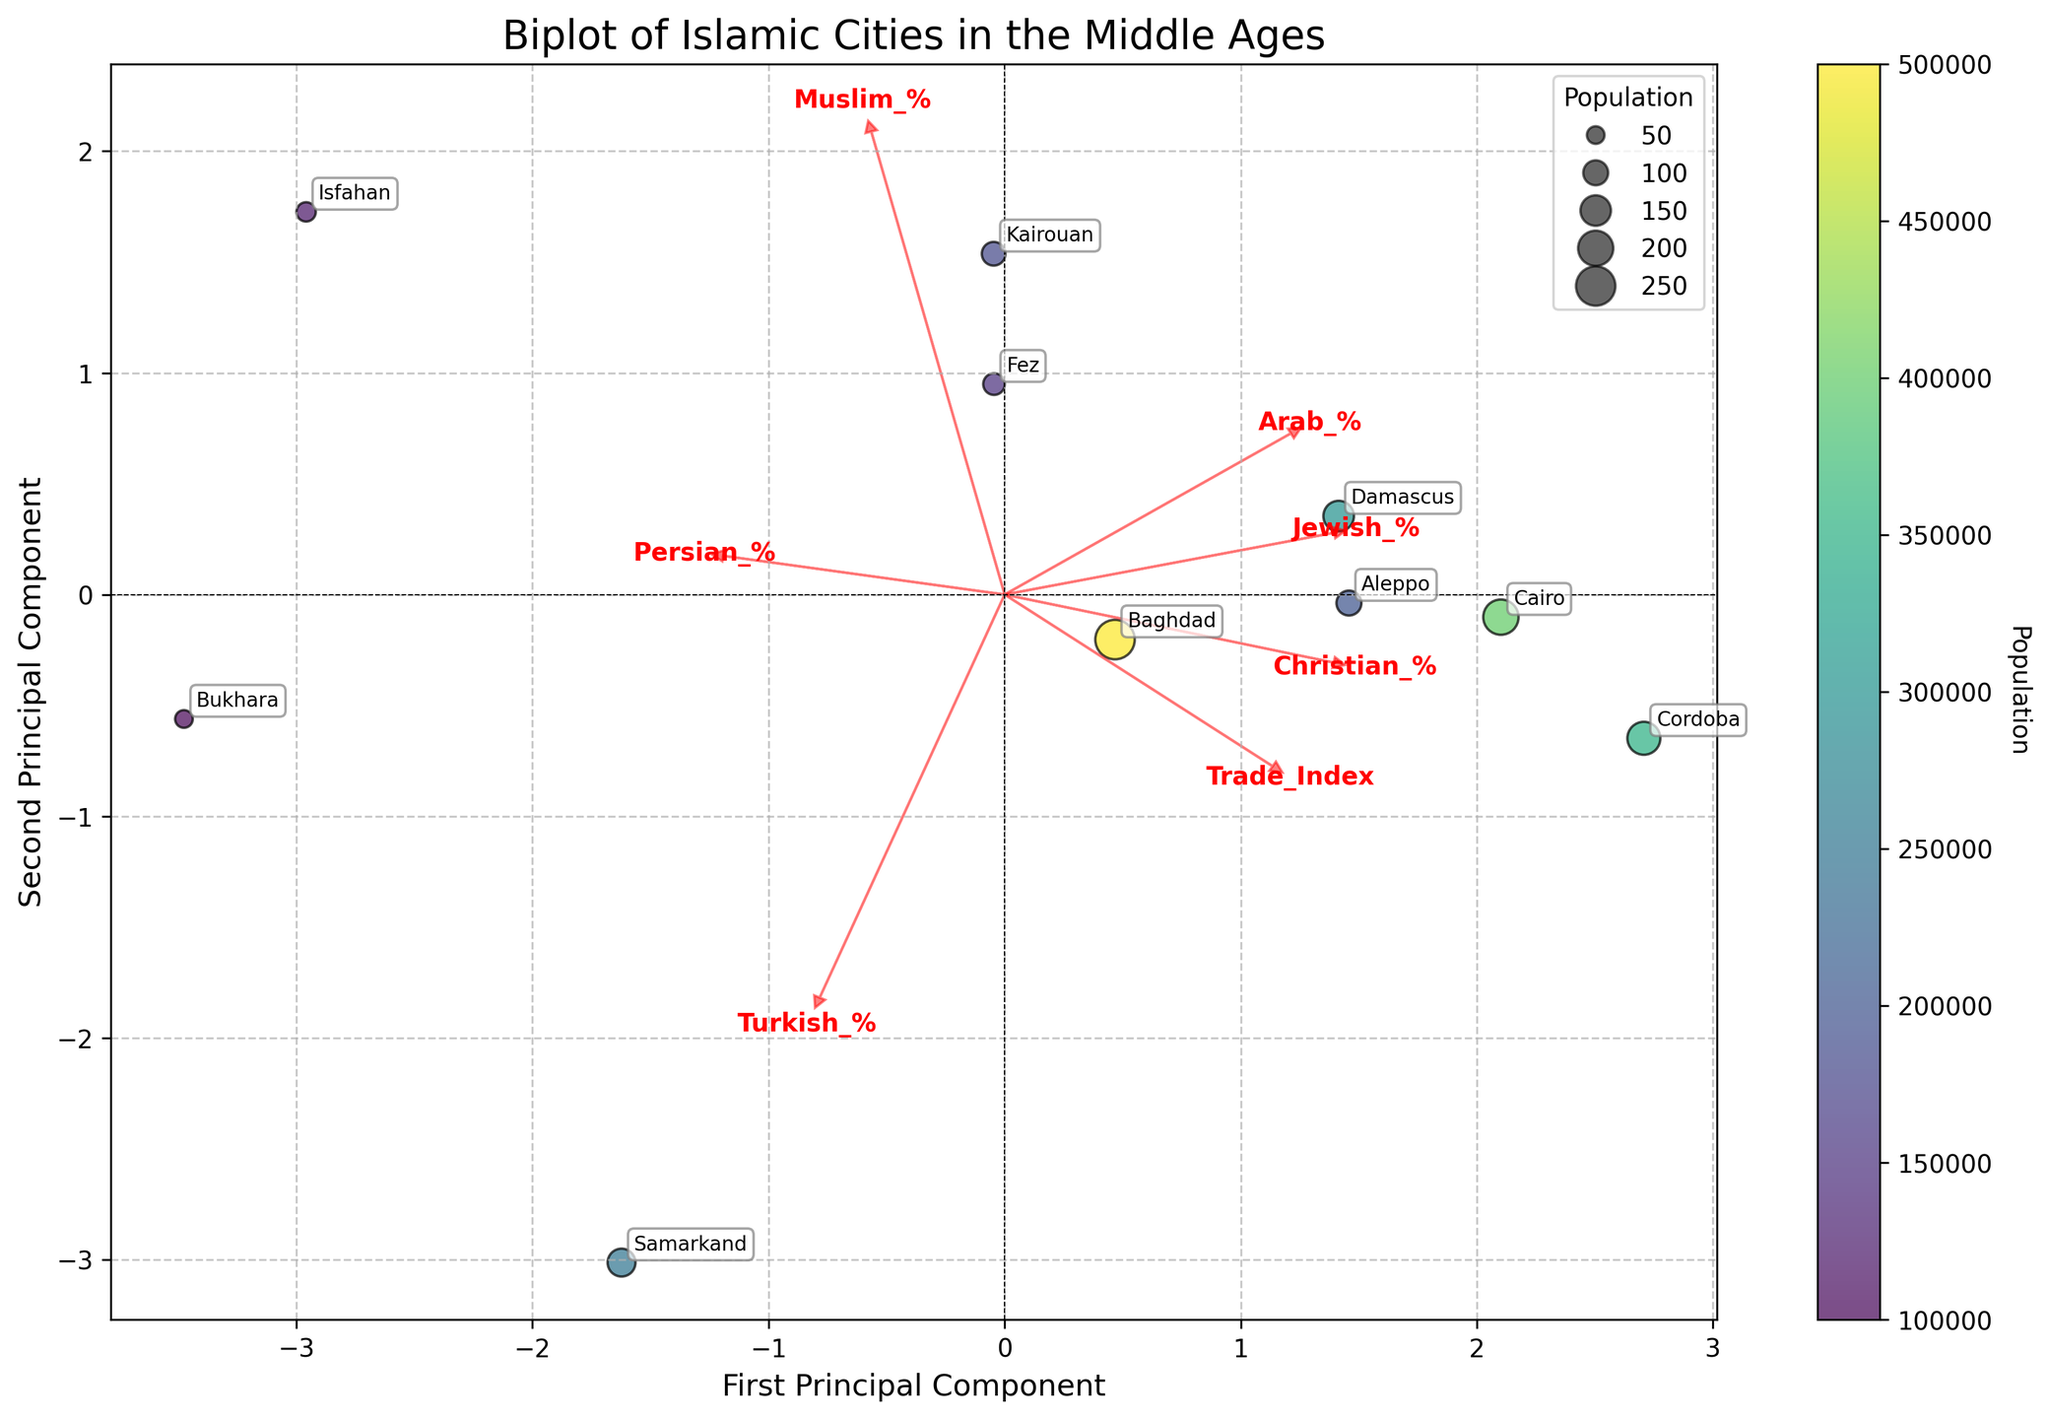What is the title of the figure? The title of the figure is written at the top and describes what the plot represents.
Answer: Biplot of Islamic Cities in the Middle Ages Which city has the highest population, and how is it indicated on the plot? The city with the highest population is indicated by the largest bubble size in the plot. By looking at the bubble sizes, Baghdad has the largest one.
Answer: Baghdad Which feature vector has the arrow with the steepest slope in the biplot? The steepest slope for a feature vector can be observed by visually comparing the angles of all arrows with respect to the horizontal axis. The 'Jewish_%' vector appears to be the steepest.
Answer: Jewish_% What is the relationship between Persian_% and Trade_Index according to the feature vectors? To determine the relationship, observe the angles between the arrows of 'Persian_%' and 'Trade_Index'. If the arrows are pointing in the same direction or close to it, they are positively correlated; otherwise, they are not. The arrows for 'Persian_%' and 'Trade_Index' point in relatively similar directions.
Answer: Positive relationship Which city appears closest to the origin in the biplot? To find the city closest to the origin, look for the data point that is nearest to the coordinate (0,0). Bukhara appears to be the closest.
Answer: Bukhara How does the Trade_Index vary among the depicted cities based on their positions in the biplot? To answer this, observe the positions of the cities along the Trade_Index vector. Cities farther along the direction of the Trade_Index vector likely have a higher trade index. Baghdad and Cairo, which are positioned along this direction, have high trade indices compared to Isfahan and Bukhara.
Answer: Varies, highest for Baghdad and Cairo Which two cities have the most similar population sizes based on their bubble sizes in the plot? To compare, look for two bubbles of nearly the same size. Aleppo and Kairouan have bubbles that are similar in size, indicating similar population sizes.
Answer: Aleppo and Kairouan What is denoted by the color of the data points? The color of the data points is usually indicated by a colorbar within the plot, which in this case, represents the population of the cities.
Answer: Population Are the cities with a higher 'Arab_%' generally positioned similarly in the biplot? By looking at the feature vector for 'Arab_%' and the relative positions of cities, determine if cities with a higher percentage of Arabs are similarly located in terms of PC1 and PC2. Cities like Baghdad, Cairo, and Damascus, which have higher Arab percentages, are positioned in a manner reflecting this vector.
Answer: Yes 